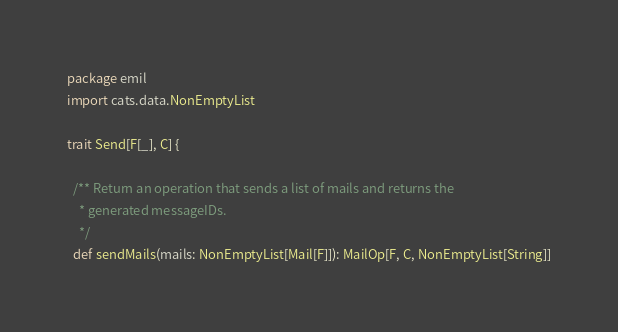Convert code to text. <code><loc_0><loc_0><loc_500><loc_500><_Scala_>package emil
import cats.data.NonEmptyList

trait Send[F[_], C] {

  /** Return an operation that sends a list of mails and returns the
    * generated messageIDs.
    */
  def sendMails(mails: NonEmptyList[Mail[F]]): MailOp[F, C, NonEmptyList[String]]
</code> 